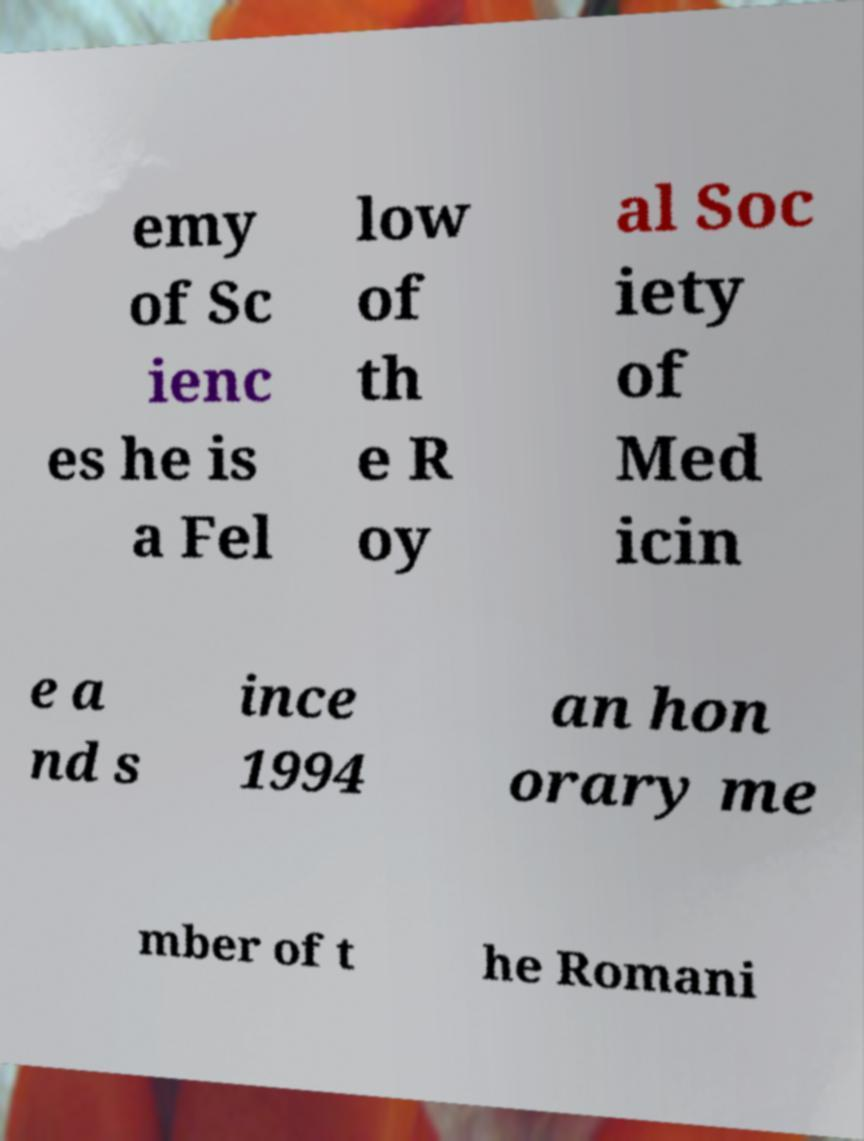Please identify and transcribe the text found in this image. emy of Sc ienc es he is a Fel low of th e R oy al Soc iety of Med icin e a nd s ince 1994 an hon orary me mber of t he Romani 